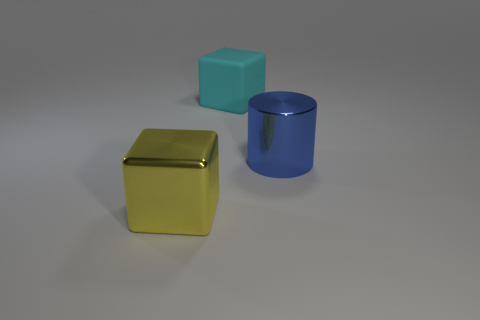What number of objects are both in front of the matte object and left of the big shiny cylinder?
Your answer should be very brief. 1. What is the size of the other thing that is the same shape as the cyan object?
Ensure brevity in your answer.  Large. What number of cubes are to the right of the blue shiny object that is to the right of the cube behind the large yellow metallic object?
Offer a very short reply. 0. There is a big shiny object that is behind the shiny object that is in front of the big blue cylinder; what is its color?
Your answer should be compact. Blue. What number of other objects are there of the same material as the large yellow block?
Give a very brief answer. 1. There is a big cube left of the cyan object; how many large things are behind it?
Provide a short and direct response. 2. Is there anything else that is the same shape as the large cyan object?
Make the answer very short. Yes. There is a big thing that is behind the big blue shiny cylinder; does it have the same color as the large block that is in front of the big blue cylinder?
Offer a very short reply. No. Are there fewer small gray metal cylinders than large yellow blocks?
Provide a short and direct response. Yes. There is a big thing that is behind the big metallic cylinder that is to the right of the yellow object; what is its shape?
Provide a succinct answer. Cube. 